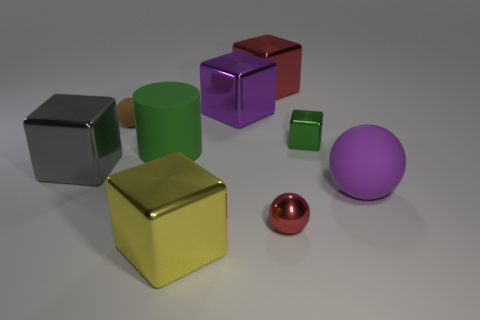What color is the metallic block behind the purple metallic object?
Offer a very short reply. Red. There is a small metal object that is in front of the gray thing; does it have the same color as the tiny cube?
Your answer should be compact. No. What is the material of the small brown object that is the same shape as the purple matte thing?
Your answer should be very brief. Rubber. How many cyan matte cubes have the same size as the purple rubber sphere?
Your answer should be compact. 0. The big green object is what shape?
Your answer should be compact. Cylinder. How big is the ball that is both left of the tiny cube and in front of the large gray metallic cube?
Keep it short and to the point. Small. What material is the sphere behind the gray block?
Ensure brevity in your answer.  Rubber. There is a big ball; does it have the same color as the big metal cube in front of the big gray metallic object?
Ensure brevity in your answer.  No. How many things are tiny green metallic blocks that are behind the large yellow object or small spheres on the left side of the red cube?
Make the answer very short. 2. There is a shiny thing that is in front of the tiny metal block and behind the red metallic ball; what color is it?
Keep it short and to the point. Gray. 